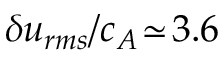<formula> <loc_0><loc_0><loc_500><loc_500>\delta u _ { r m s } / c _ { A } \, \simeq \, 3 . 6</formula> 